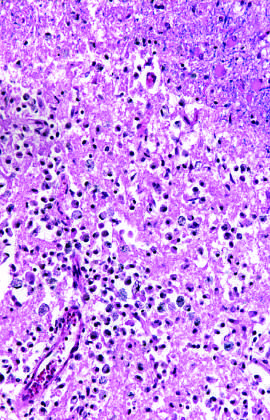what are seen as areas of tissue loss and residual gliosis?
Answer the question using a single word or phrase. Old intracortical infarcts 